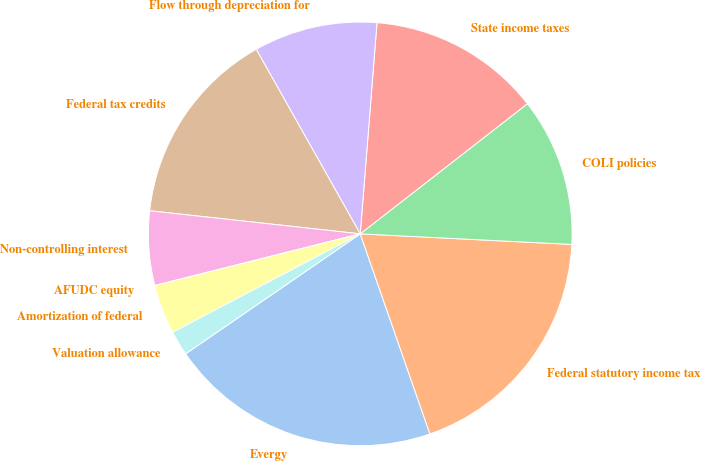Convert chart. <chart><loc_0><loc_0><loc_500><loc_500><pie_chart><fcel>Evergy<fcel>Federal statutory income tax<fcel>COLI policies<fcel>State income taxes<fcel>Flow through depreciation for<fcel>Federal tax credits<fcel>Non-controlling interest<fcel>AFUDC equity<fcel>Amortization of federal<fcel>Valuation allowance<nl><fcel>20.75%<fcel>18.87%<fcel>11.32%<fcel>13.21%<fcel>9.43%<fcel>15.09%<fcel>5.66%<fcel>0.0%<fcel>3.77%<fcel>1.89%<nl></chart> 